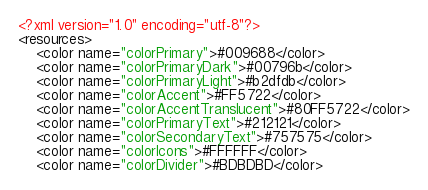<code> <loc_0><loc_0><loc_500><loc_500><_XML_><?xml version="1.0" encoding="utf-8"?>
<resources>
    <color name="colorPrimary">#009688</color>
    <color name="colorPrimaryDark">#00796b</color>
    <color name="colorPrimaryLight">#b2dfdb</color>
    <color name="colorAccent">#FF5722</color>
    <color name="colorAccentTranslucent">#80FF5722</color>
    <color name="colorPrimaryText">#212121</color>
    <color name="colorSecondaryText">#757575</color>
    <color name="colorIcons">#FFFFFF</color>
    <color name="colorDivider">#BDBDBD</color>
</code> 